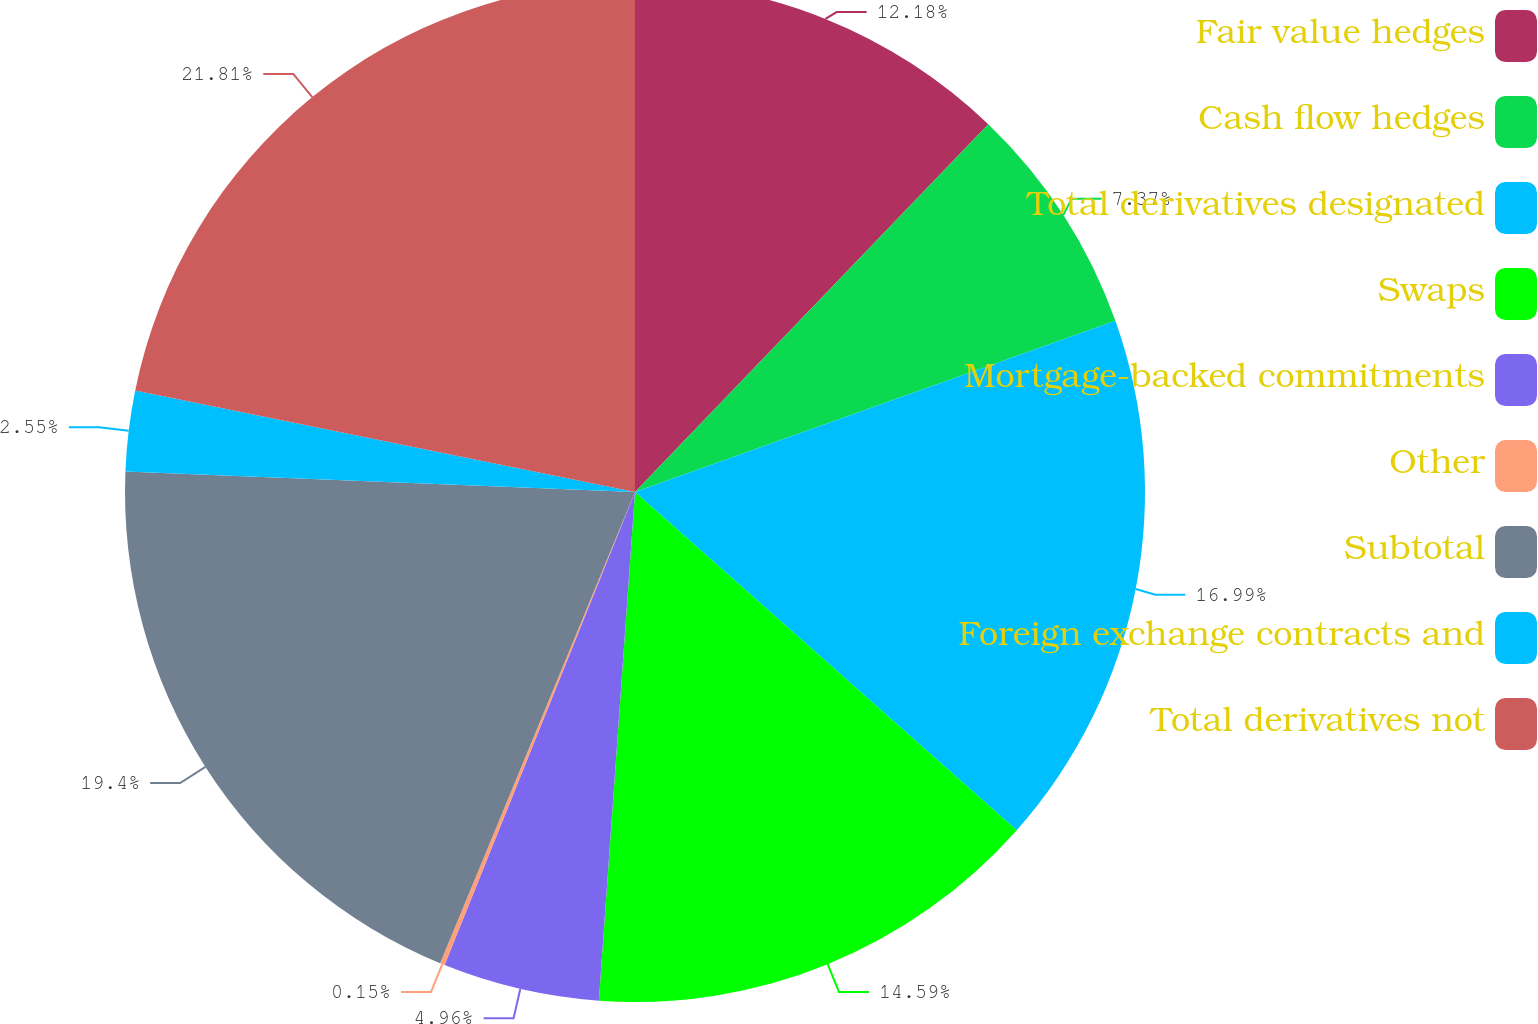Convert chart to OTSL. <chart><loc_0><loc_0><loc_500><loc_500><pie_chart><fcel>Fair value hedges<fcel>Cash flow hedges<fcel>Total derivatives designated<fcel>Swaps<fcel>Mortgage-backed commitments<fcel>Other<fcel>Subtotal<fcel>Foreign exchange contracts and<fcel>Total derivatives not<nl><fcel>12.18%<fcel>7.37%<fcel>16.99%<fcel>14.59%<fcel>4.96%<fcel>0.15%<fcel>19.4%<fcel>2.55%<fcel>21.81%<nl></chart> 